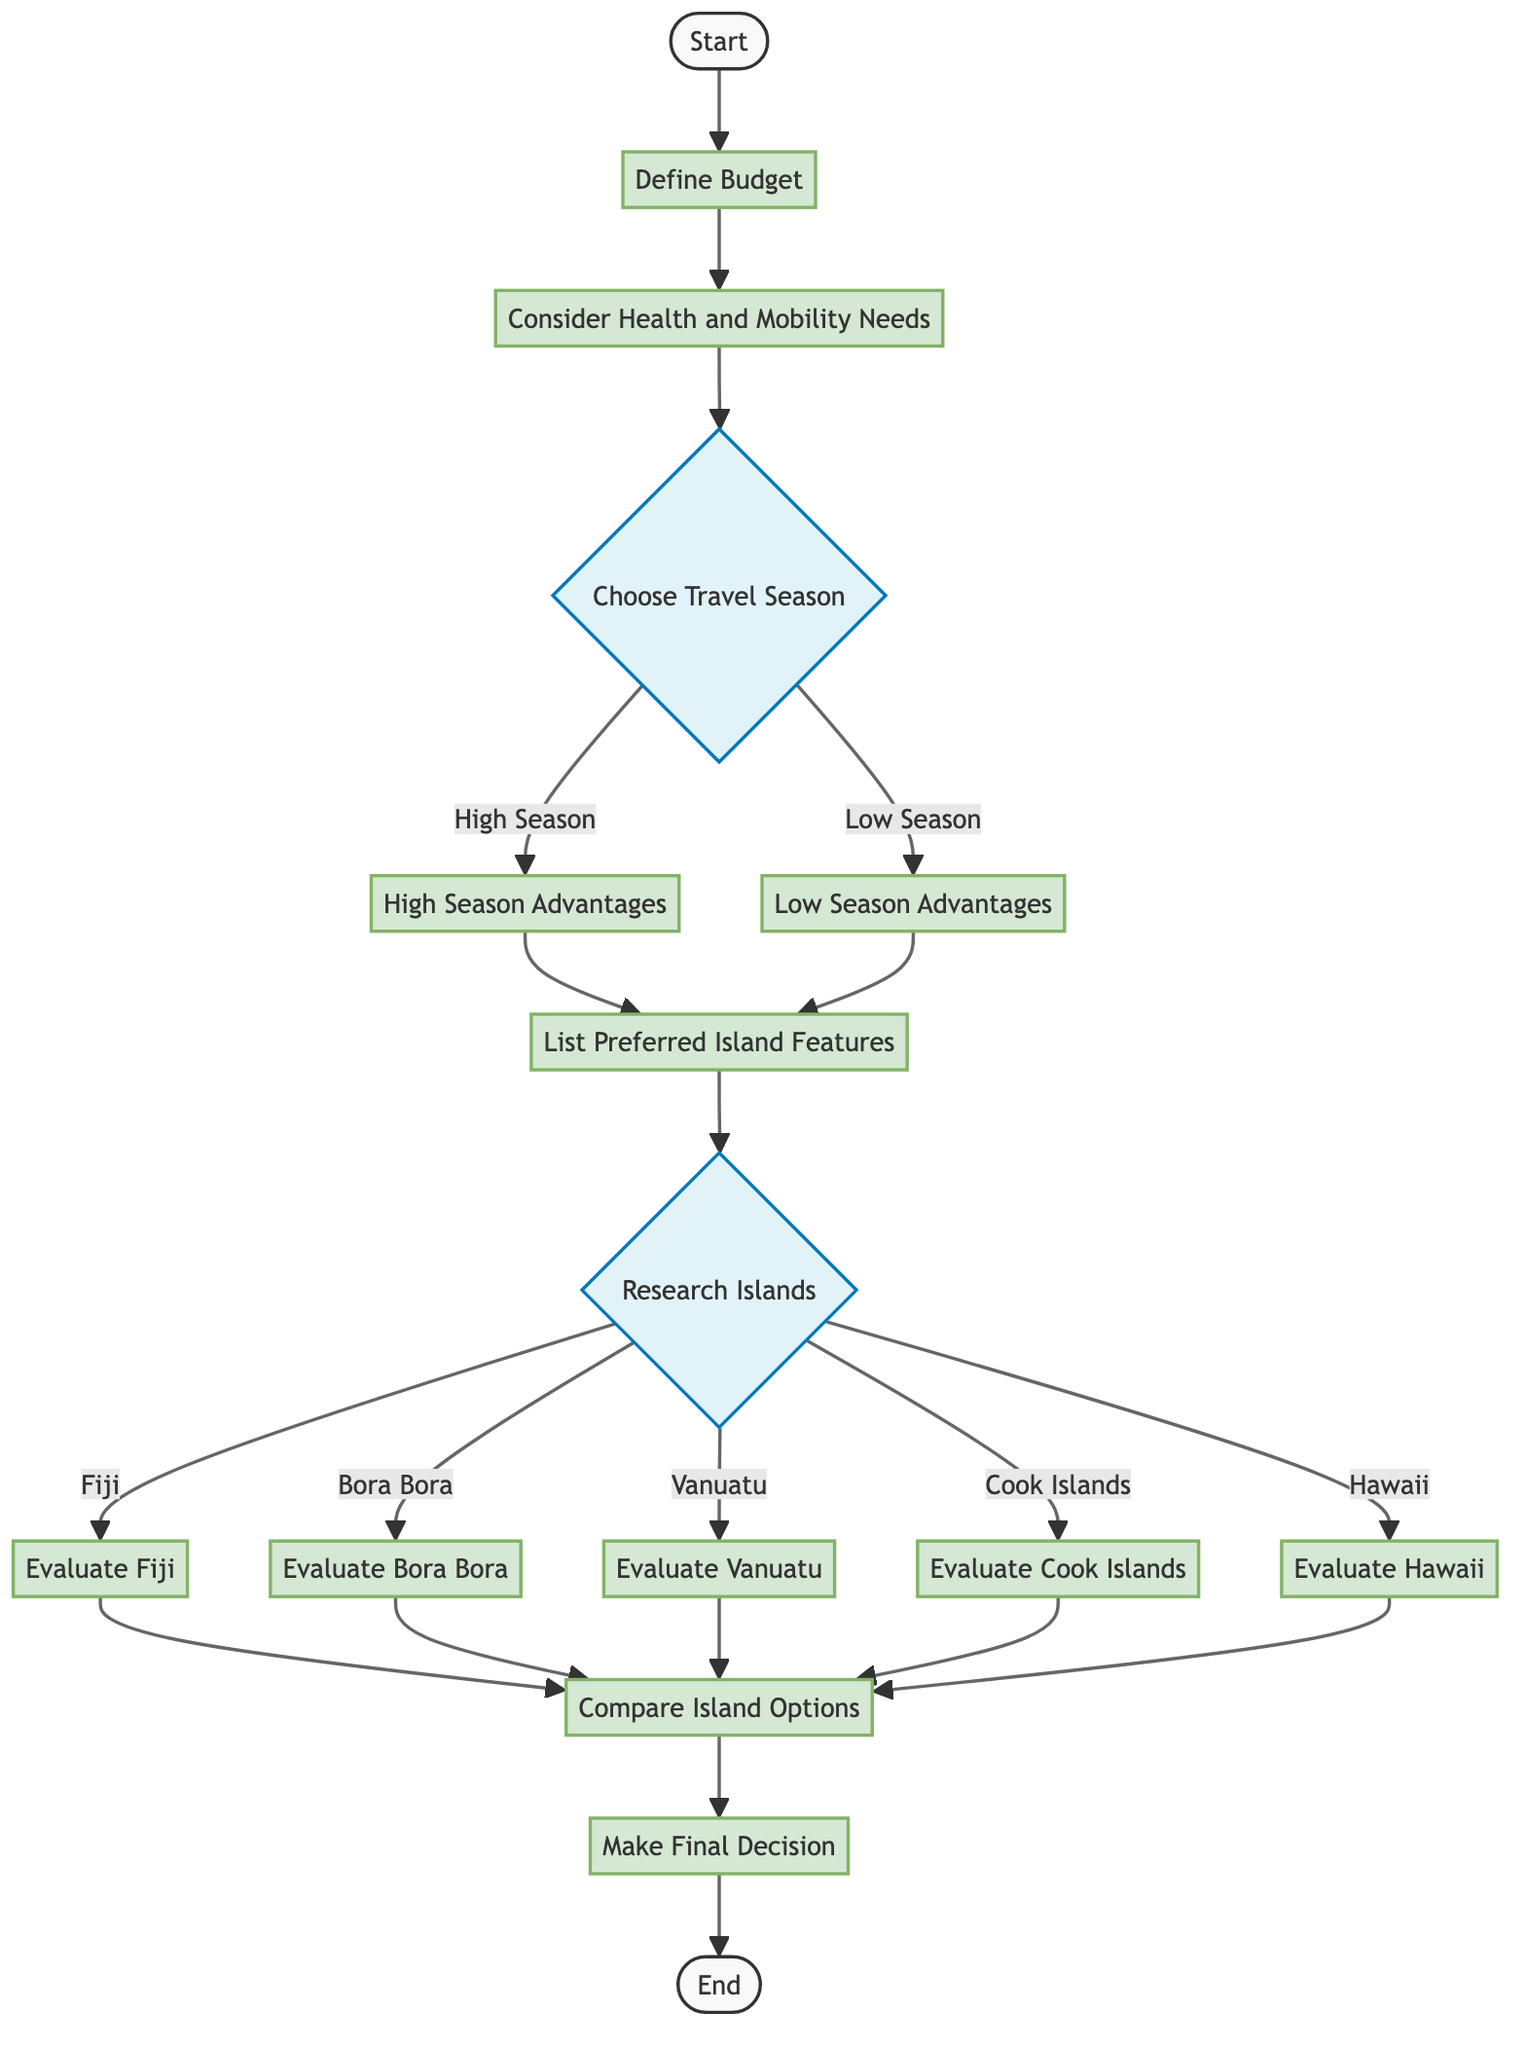What is the first step in the vacation decision-making process? The first step in the process is "Define Budget," which is indicated as the starting point connecting to the next node.
Answer: Define Budget How many islands can you research before making a decision? There are five options for islands listed under "Research Islands," which are Fiji, Bora Bora, Vanuatu, Cook Islands, and Hawaii.
Answer: Five What does the decision node "Choose Travel Season" lead to? The decision node "Choose Travel Season" leads to two different options: "High Season" and "Low Season," indicating that the flow can take two paths based on this choice.
Answer: High Season and Low Season After evaluating an island, what is the next step according to the flowchart? After evaluating an island, the next step is "Compare Island Options," which follows directly after the evaluation of islands.
Answer: Compare Island Options What are the preferred island features listed before researching islands? The preferred island features listed are "Sandy Beaches, Crystal Clear Waters, Cultural Sites, Wildlife," detailed in the process before moving on to the research stage.
Answer: Sandy Beaches, Crystal Clear Waters, Cultural Sites, Wildlife If you choose the low season, what node comes next in the diagram? If the low season is chosen, it leads to the "Low Season Advantages," which is the process that follows the "Choose Travel Season" decision.
Answer: Low Season Advantages What are the final steps before reaching the end of the flowchart? The final steps before reaching the end are "Make Final Decision" followed by "End," indicating the conclusion of the vacation choice process.
Answer: Make Final Decision, End Which two nodes connect directly to "List Preferred Island Features"? "High Season Advantages" and "Low Season Advantages" connect directly to "List Preferred Island Features," showing the results of the decision made earlier in the process.
Answer: High Season Advantages, Low Season Advantages What happens after comparing island options? After comparing island options, the next step is to "Make Final Decision," which is a finalizing stage in the decision-making process.
Answer: Make Final Decision 